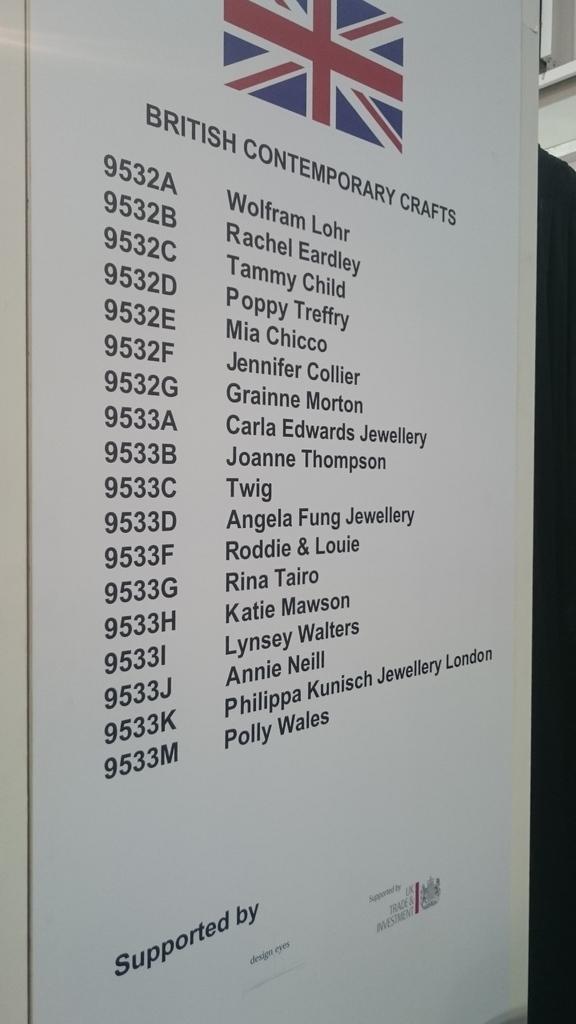What kind of comtemporary crafts?
Offer a terse response. British. What number is joanne thompson?
Ensure brevity in your answer.  9533b. 